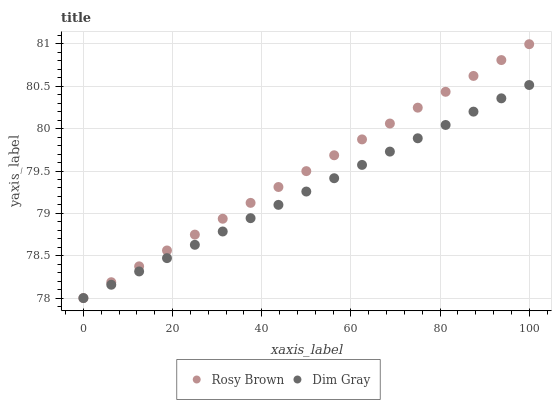Does Dim Gray have the minimum area under the curve?
Answer yes or no. Yes. Does Rosy Brown have the maximum area under the curve?
Answer yes or no. Yes. Does Rosy Brown have the minimum area under the curve?
Answer yes or no. No. Is Rosy Brown the smoothest?
Answer yes or no. Yes. Is Dim Gray the roughest?
Answer yes or no. Yes. Is Rosy Brown the roughest?
Answer yes or no. No. Does Dim Gray have the lowest value?
Answer yes or no. Yes. Does Rosy Brown have the highest value?
Answer yes or no. Yes. Does Dim Gray intersect Rosy Brown?
Answer yes or no. Yes. Is Dim Gray less than Rosy Brown?
Answer yes or no. No. Is Dim Gray greater than Rosy Brown?
Answer yes or no. No. 